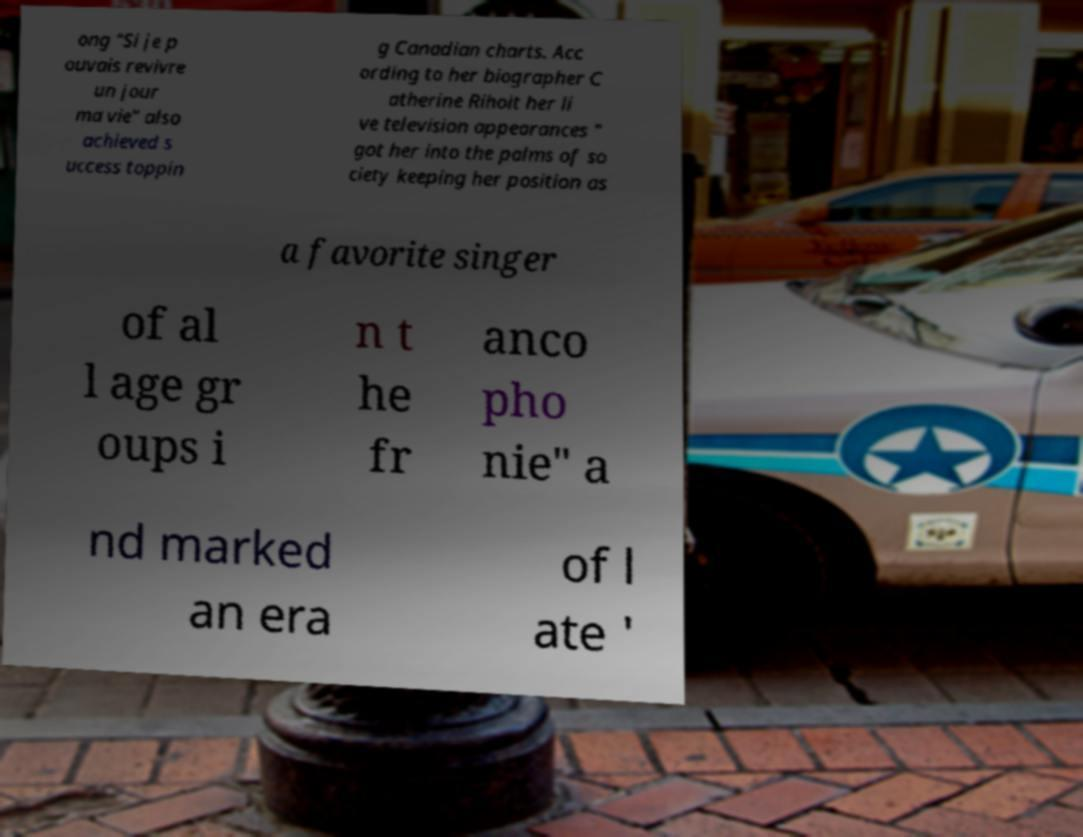Could you extract and type out the text from this image? ong "Si je p ouvais revivre un jour ma vie" also achieved s uccess toppin g Canadian charts. Acc ording to her biographer C atherine Rihoit her li ve television appearances " got her into the palms of so ciety keeping her position as a favorite singer of al l age gr oups i n t he fr anco pho nie" a nd marked an era of l ate ' 